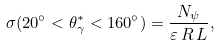<formula> <loc_0><loc_0><loc_500><loc_500>\sigma ( 2 0 ^ { \circ } < \theta _ { \gamma } ^ { \ast } < 1 6 0 ^ { \circ } ) = \frac { N _ { \psi } } { \varepsilon \, R \, L } ,</formula> 